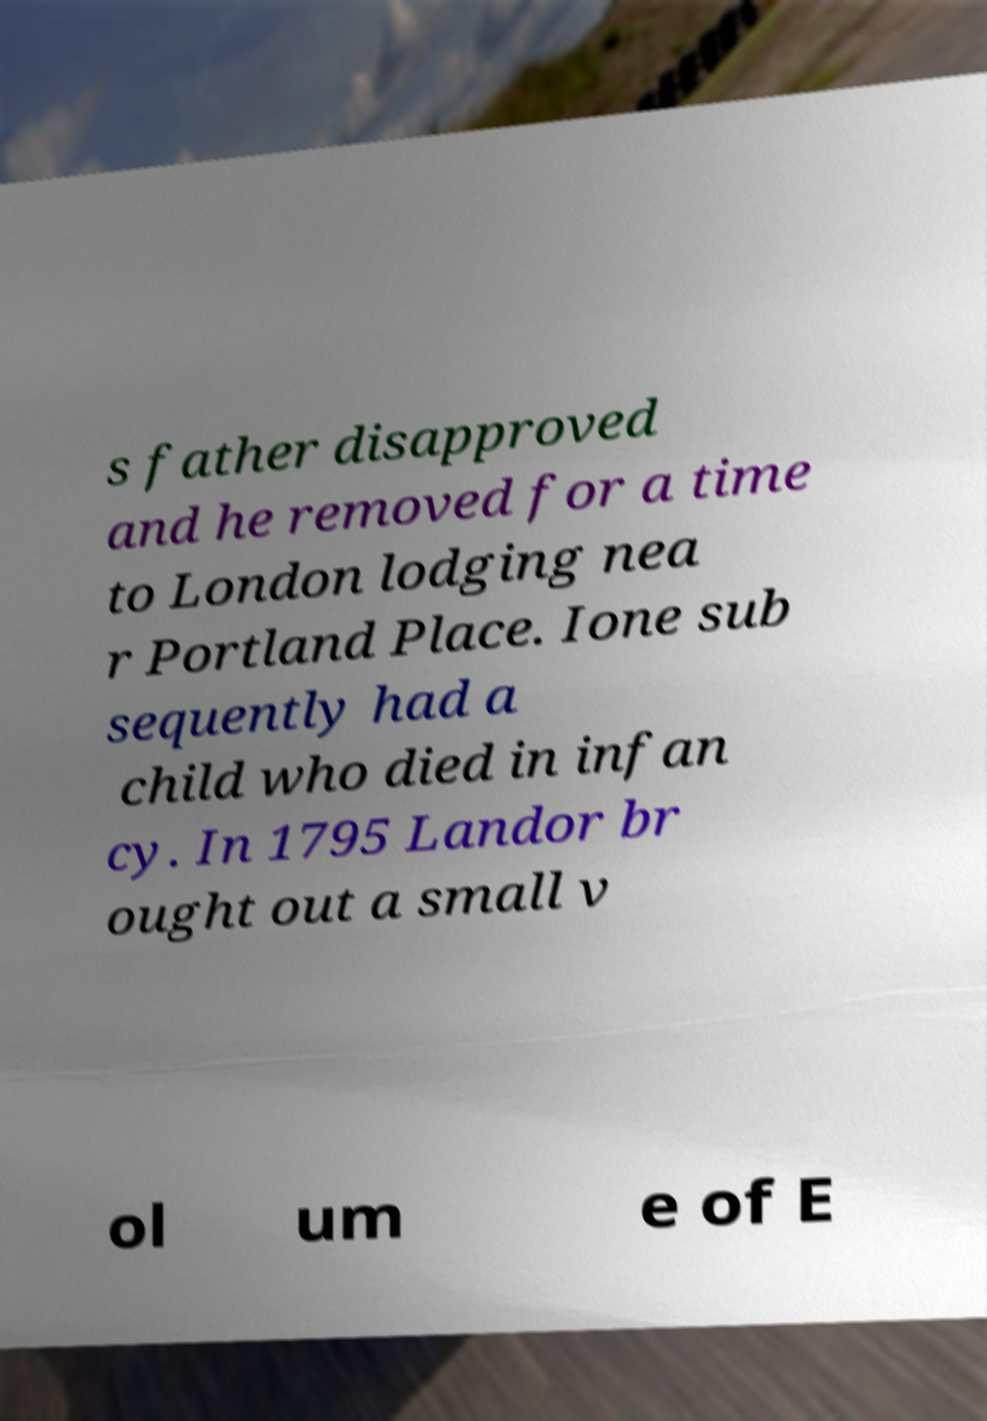Please read and relay the text visible in this image. What does it say? s father disapproved and he removed for a time to London lodging nea r Portland Place. Ione sub sequently had a child who died in infan cy. In 1795 Landor br ought out a small v ol um e of E 